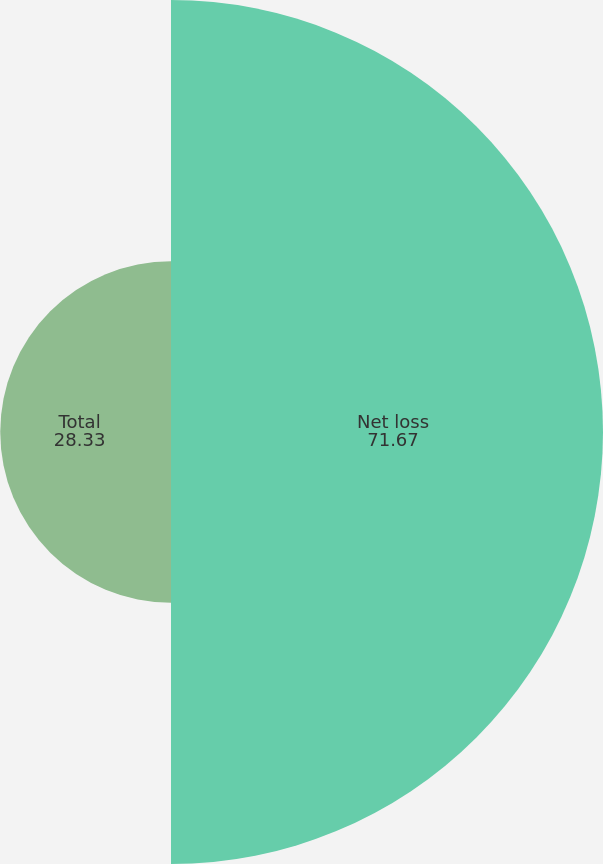Convert chart to OTSL. <chart><loc_0><loc_0><loc_500><loc_500><pie_chart><fcel>Net loss<fcel>Total<nl><fcel>71.67%<fcel>28.33%<nl></chart> 